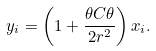Convert formula to latex. <formula><loc_0><loc_0><loc_500><loc_500>y _ { i } = \left ( 1 + \frac { \theta C \theta } { 2 r ^ { 2 } } \right ) x _ { i } .</formula> 